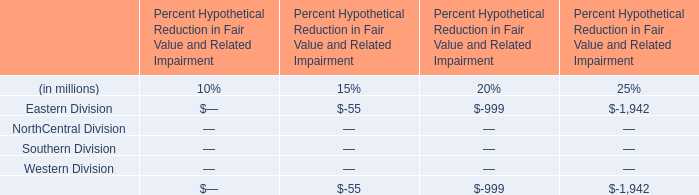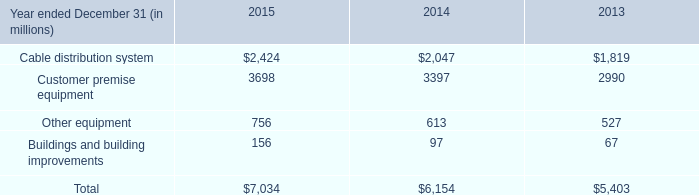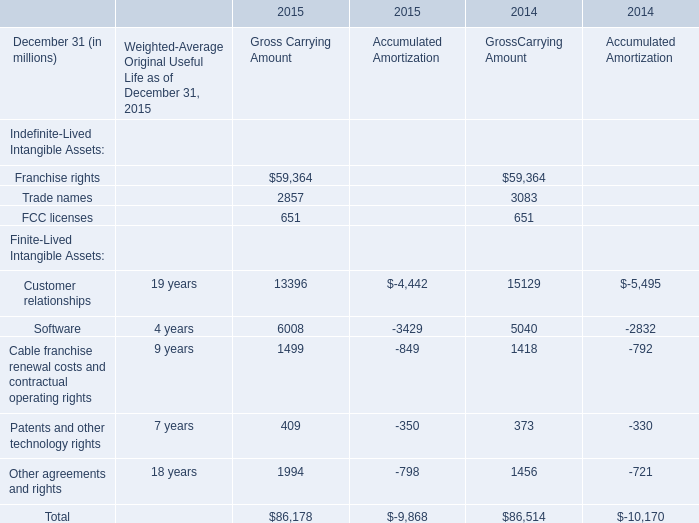In which years is Franchise rights greater than Trade names for Gross Carrying Amount? 
Answer: 2015 2014. 